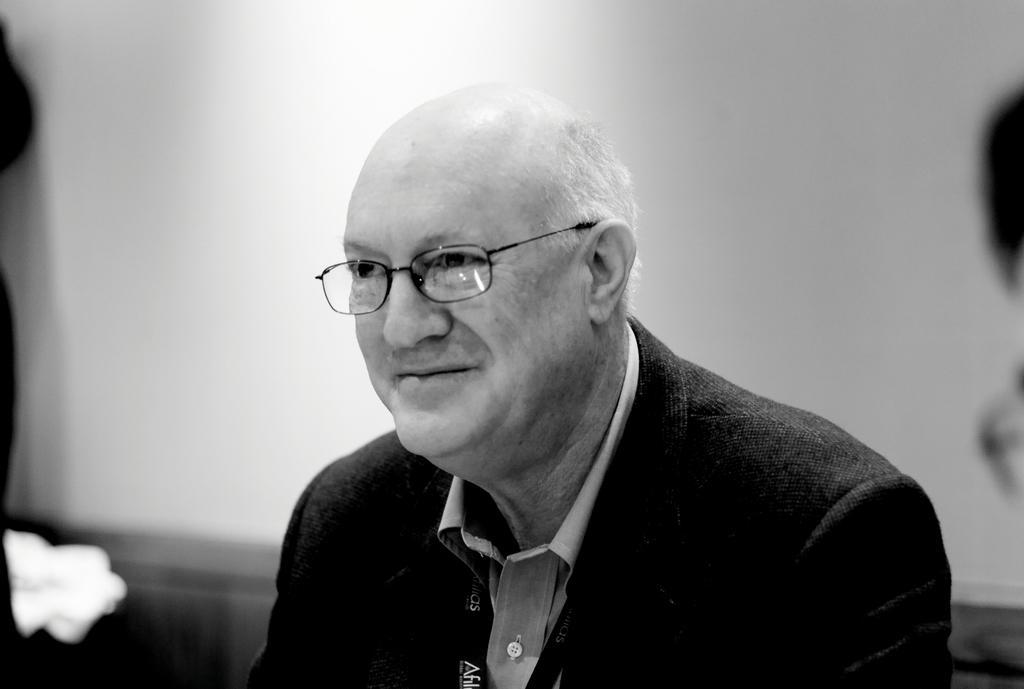Can you describe this image briefly? In this picture, we can see a black and white image of an old person, and we can see the blurred background. 